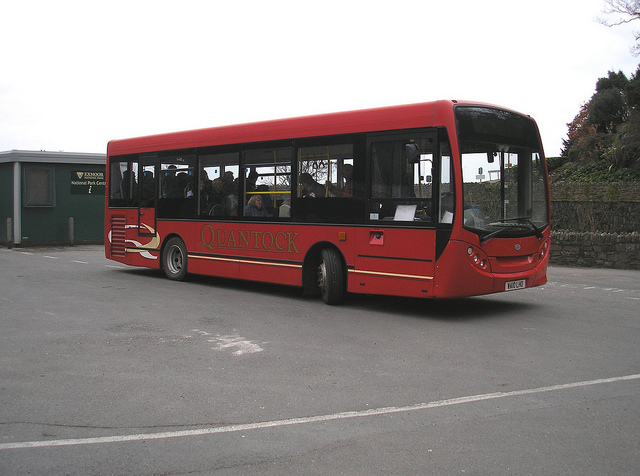Extract all visible text content from this image. QUANTOCK Q 